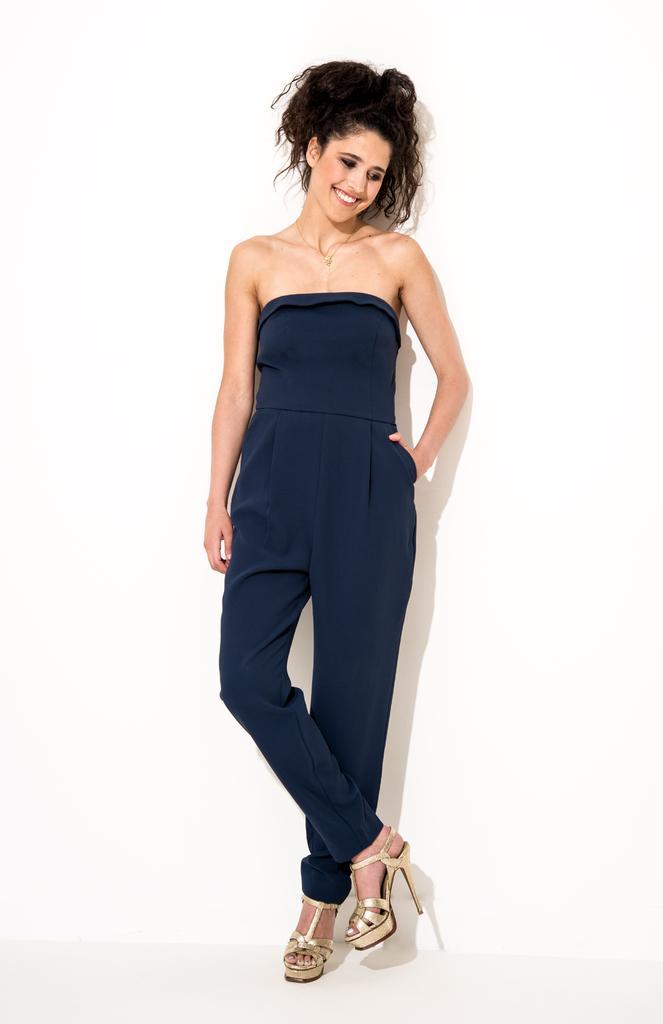Could you give a brief overview of what you see in this image? In this image we can see a woman standing on the floor beside a wall. 